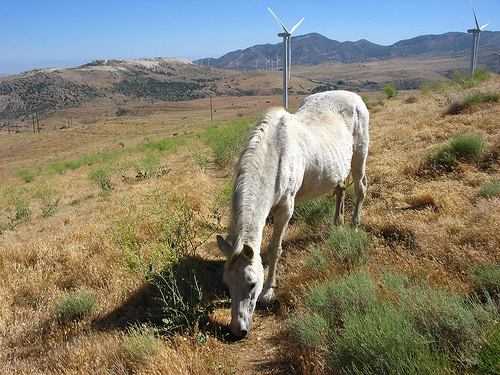<image>
Can you confirm if the tower is in front of the mountain? Yes. The tower is positioned in front of the mountain, appearing closer to the camera viewpoint. 